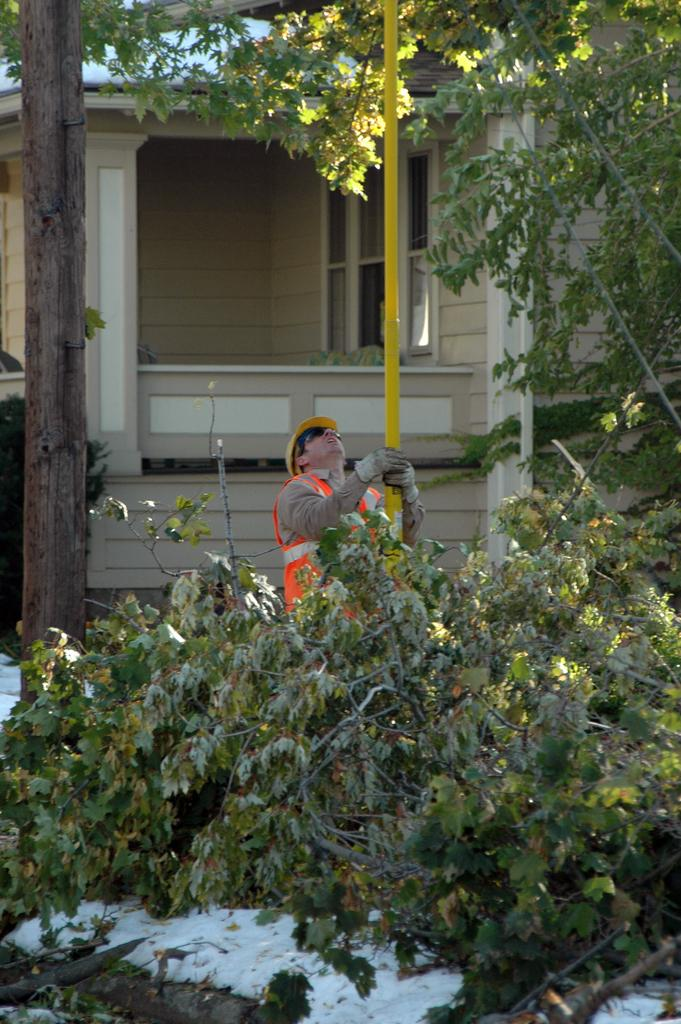What can be seen in the image? There is a person in the image. What is the person wearing? The person is wearing gloves, goggles, and a cap. What is the person holding? The person is holding a pole. What is located near the person? There is a tree in the image, and branches are on the ground. What can be seen in the background of the image? There is a building in the background, which has windows and pillars. What type of paste is being used by the person to climb the tree in the image? There is no paste visible in the image, and the person is not climbing the tree. 